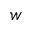<formula> <loc_0><loc_0><loc_500><loc_500>w</formula> 